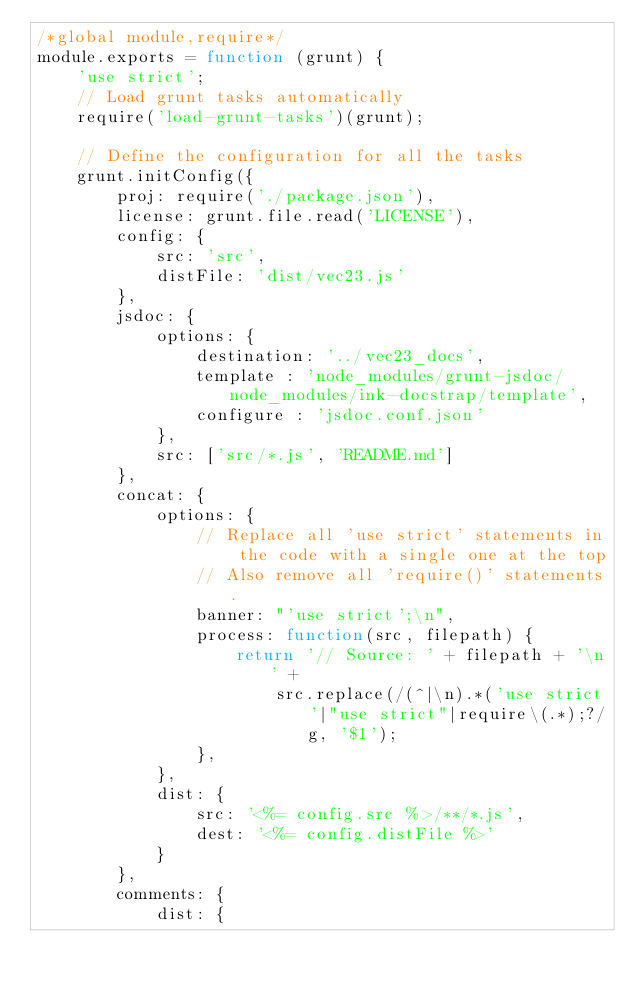Convert code to text. <code><loc_0><loc_0><loc_500><loc_500><_JavaScript_>/*global module,require*/
module.exports = function (grunt) {
    'use strict';
    // Load grunt tasks automatically
    require('load-grunt-tasks')(grunt);

    // Define the configuration for all the tasks
    grunt.initConfig({
        proj: require('./package.json'),
        license: grunt.file.read('LICENSE'),
        config: {
            src: 'src',
            distFile: 'dist/vec23.js'
        },
        jsdoc: {
            options: {
                destination: '../vec23_docs',
                template : 'node_modules/grunt-jsdoc/node_modules/ink-docstrap/template',
                configure : 'jsdoc.conf.json'
            },
            src: ['src/*.js', 'README.md']
        },
        concat: {
            options: {
                // Replace all 'use strict' statements in the code with a single one at the top
                // Also remove all 'require()' statements.
                banner: "'use strict';\n",
                process: function(src, filepath) {
                    return '// Source: ' + filepath + '\n' +
                        src.replace(/(^|\n).*('use strict'|"use strict"|require\(.*);?/g, '$1');
                },
            },
            dist: {
                src: '<%= config.src %>/**/*.js',
                dest: '<%= config.distFile %>'
            }
        },
        comments: {
            dist: {</code> 